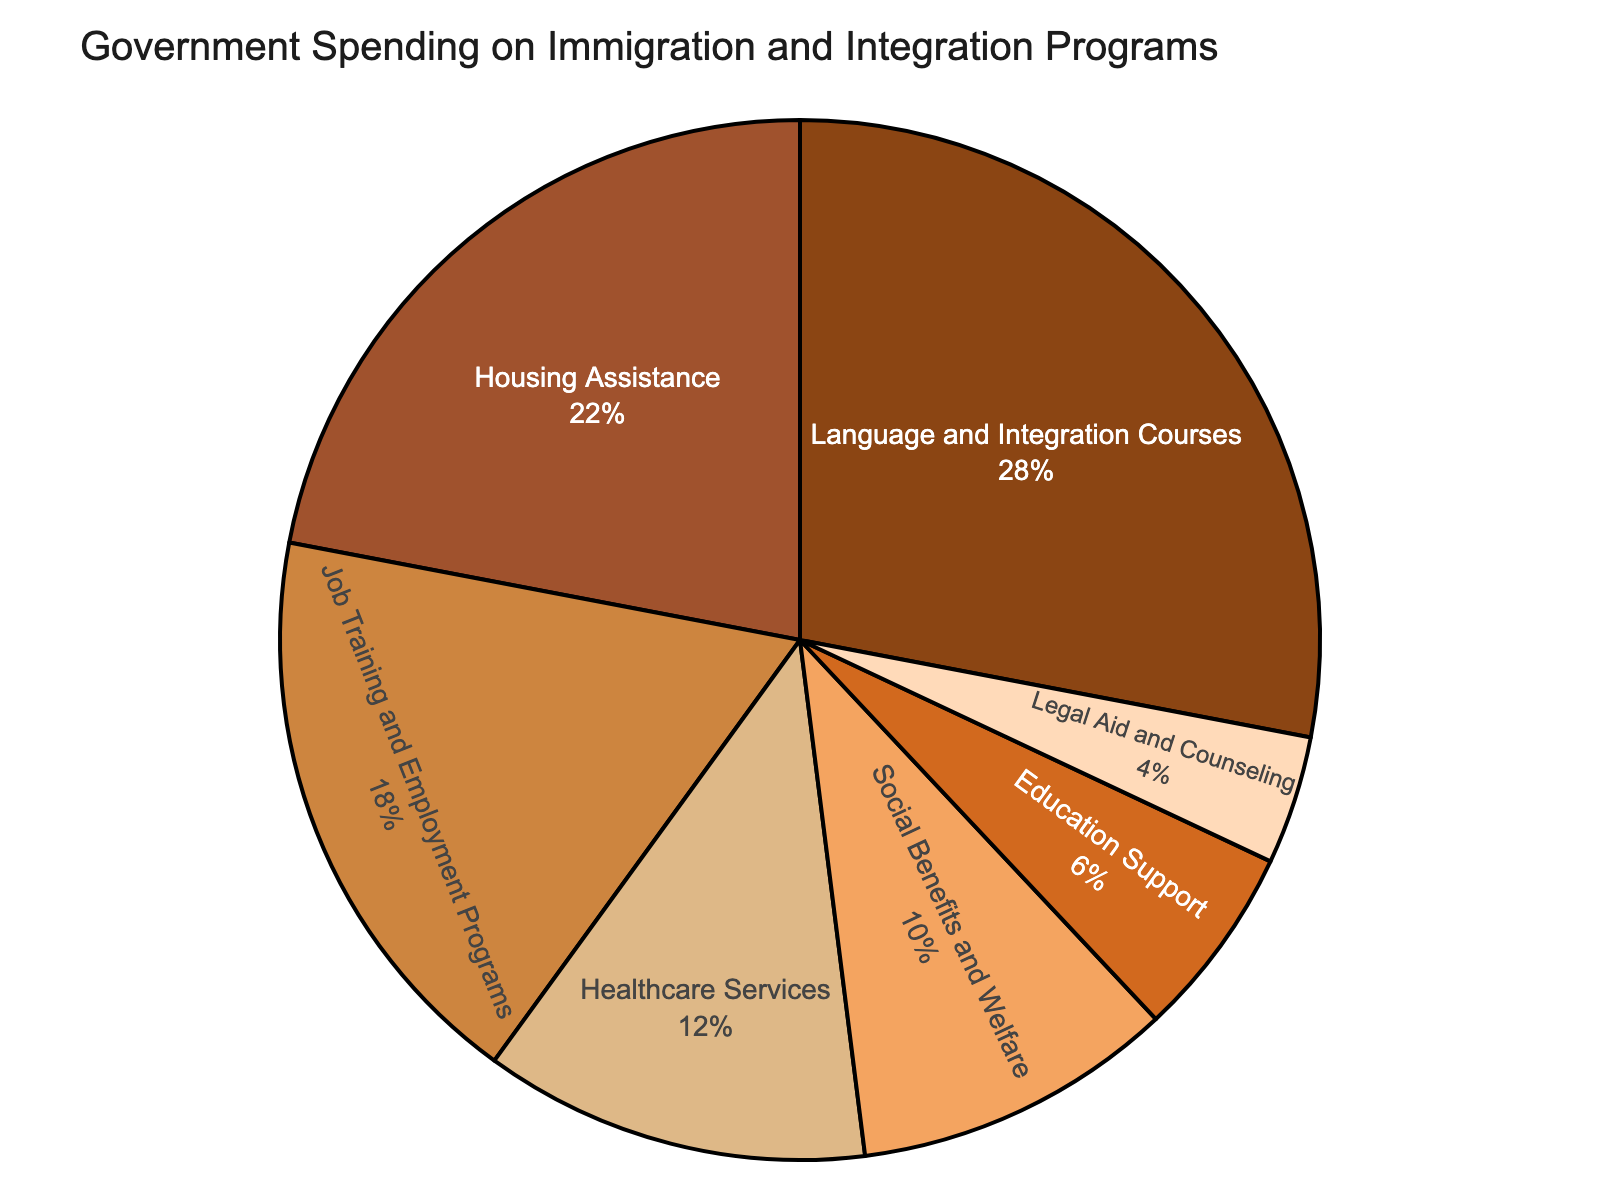What percentage of government spending is allocated to Healthcare Services? By looking at the pie chart, we can see that the section labeled 'Healthcare Services' shows its corresponding percentage.
Answer: 12% Which category receives the highest percentage of government spending? The largest slice of the pie chart corresponds to the 'Language and Integration Courses' category, so that category receives the highest percentage.
Answer: Language and Integration Courses How much more is spent on Job Training and Employment Programs compared to Legal Aid and Counseling? The percentage of spending on Job Training and Employment Programs is 18%, and on Legal Aid and Counseling, it is 4%. Subtracting these gives 18% - 4%.
Answer: 14% What is the combined percentage of government spending on Education Support and Housing Assistance? The pie chart shows that the percentage for Housing Assistance is 22% and for Education Support is 6%. Adding these gives 22% + 6%.
Answer: 28% Does the percentage spent on Social Benefits and Welfare exceed that spent on Education Support? The pie chart indicates that Social Benefits and Welfare have 10%, while Education Support has 6%. 10% is indeed greater than 6%.
Answer: Yes Rank the categories from highest to lowest based on their percentage of government spending. From the pie chart, the slices can be ranked based on their percentage as follows: 1) Language and Integration Courses (28%), 2) Housing Assistance (22%), 3) Job Training and Employment Programs (18%), 4) Healthcare Services (12%), 5) Social Benefits and Welfare (10%), 6) Education Support (6%), 7) Legal Aid and Counseling (4%).
Answer: Language and Integration Courses, Housing Assistance, Job Training and Employment Programs, Healthcare Services, Social Benefits and Welfare, Education Support, Legal Aid and Counseling What is the total percentage of government spending on the three smallest categories? The three smallest categories based on the pie chart are Legal Aid and Counseling (4%), Education Support (6%), and Social Benefits and Welfare (10%). Adding these gives 4% + 6% + 10%.
Answer: 20% How does the spending on Housing Assistance compare to the combined spending on Healthcare Services and Education Support? The pie chart shows that Housing Assistance is at 22%, Healthcare Services at 12%, and Education Support at 6%. The combined percentage for Healthcare Services and Education Support is 12% + 6% = 18%, which is less than Housing Assistance (22%).
Answer: Housing Assistance is higher If the combined spending on all categories is 100%, what fraction of the total spending does Job Training and Employment Programs represent? The pie chart indicates that Job Training and Employment Programs represent 18% of the total 100%. So, the fraction is 18/100.
Answer: 0.18 Which visual attribute can help identify the highest allocation category? The highest allocation category will have the largest slice in the pie chart. This is visually identifiable by the relative size of each slice compared to others.
Answer: Largest slice 